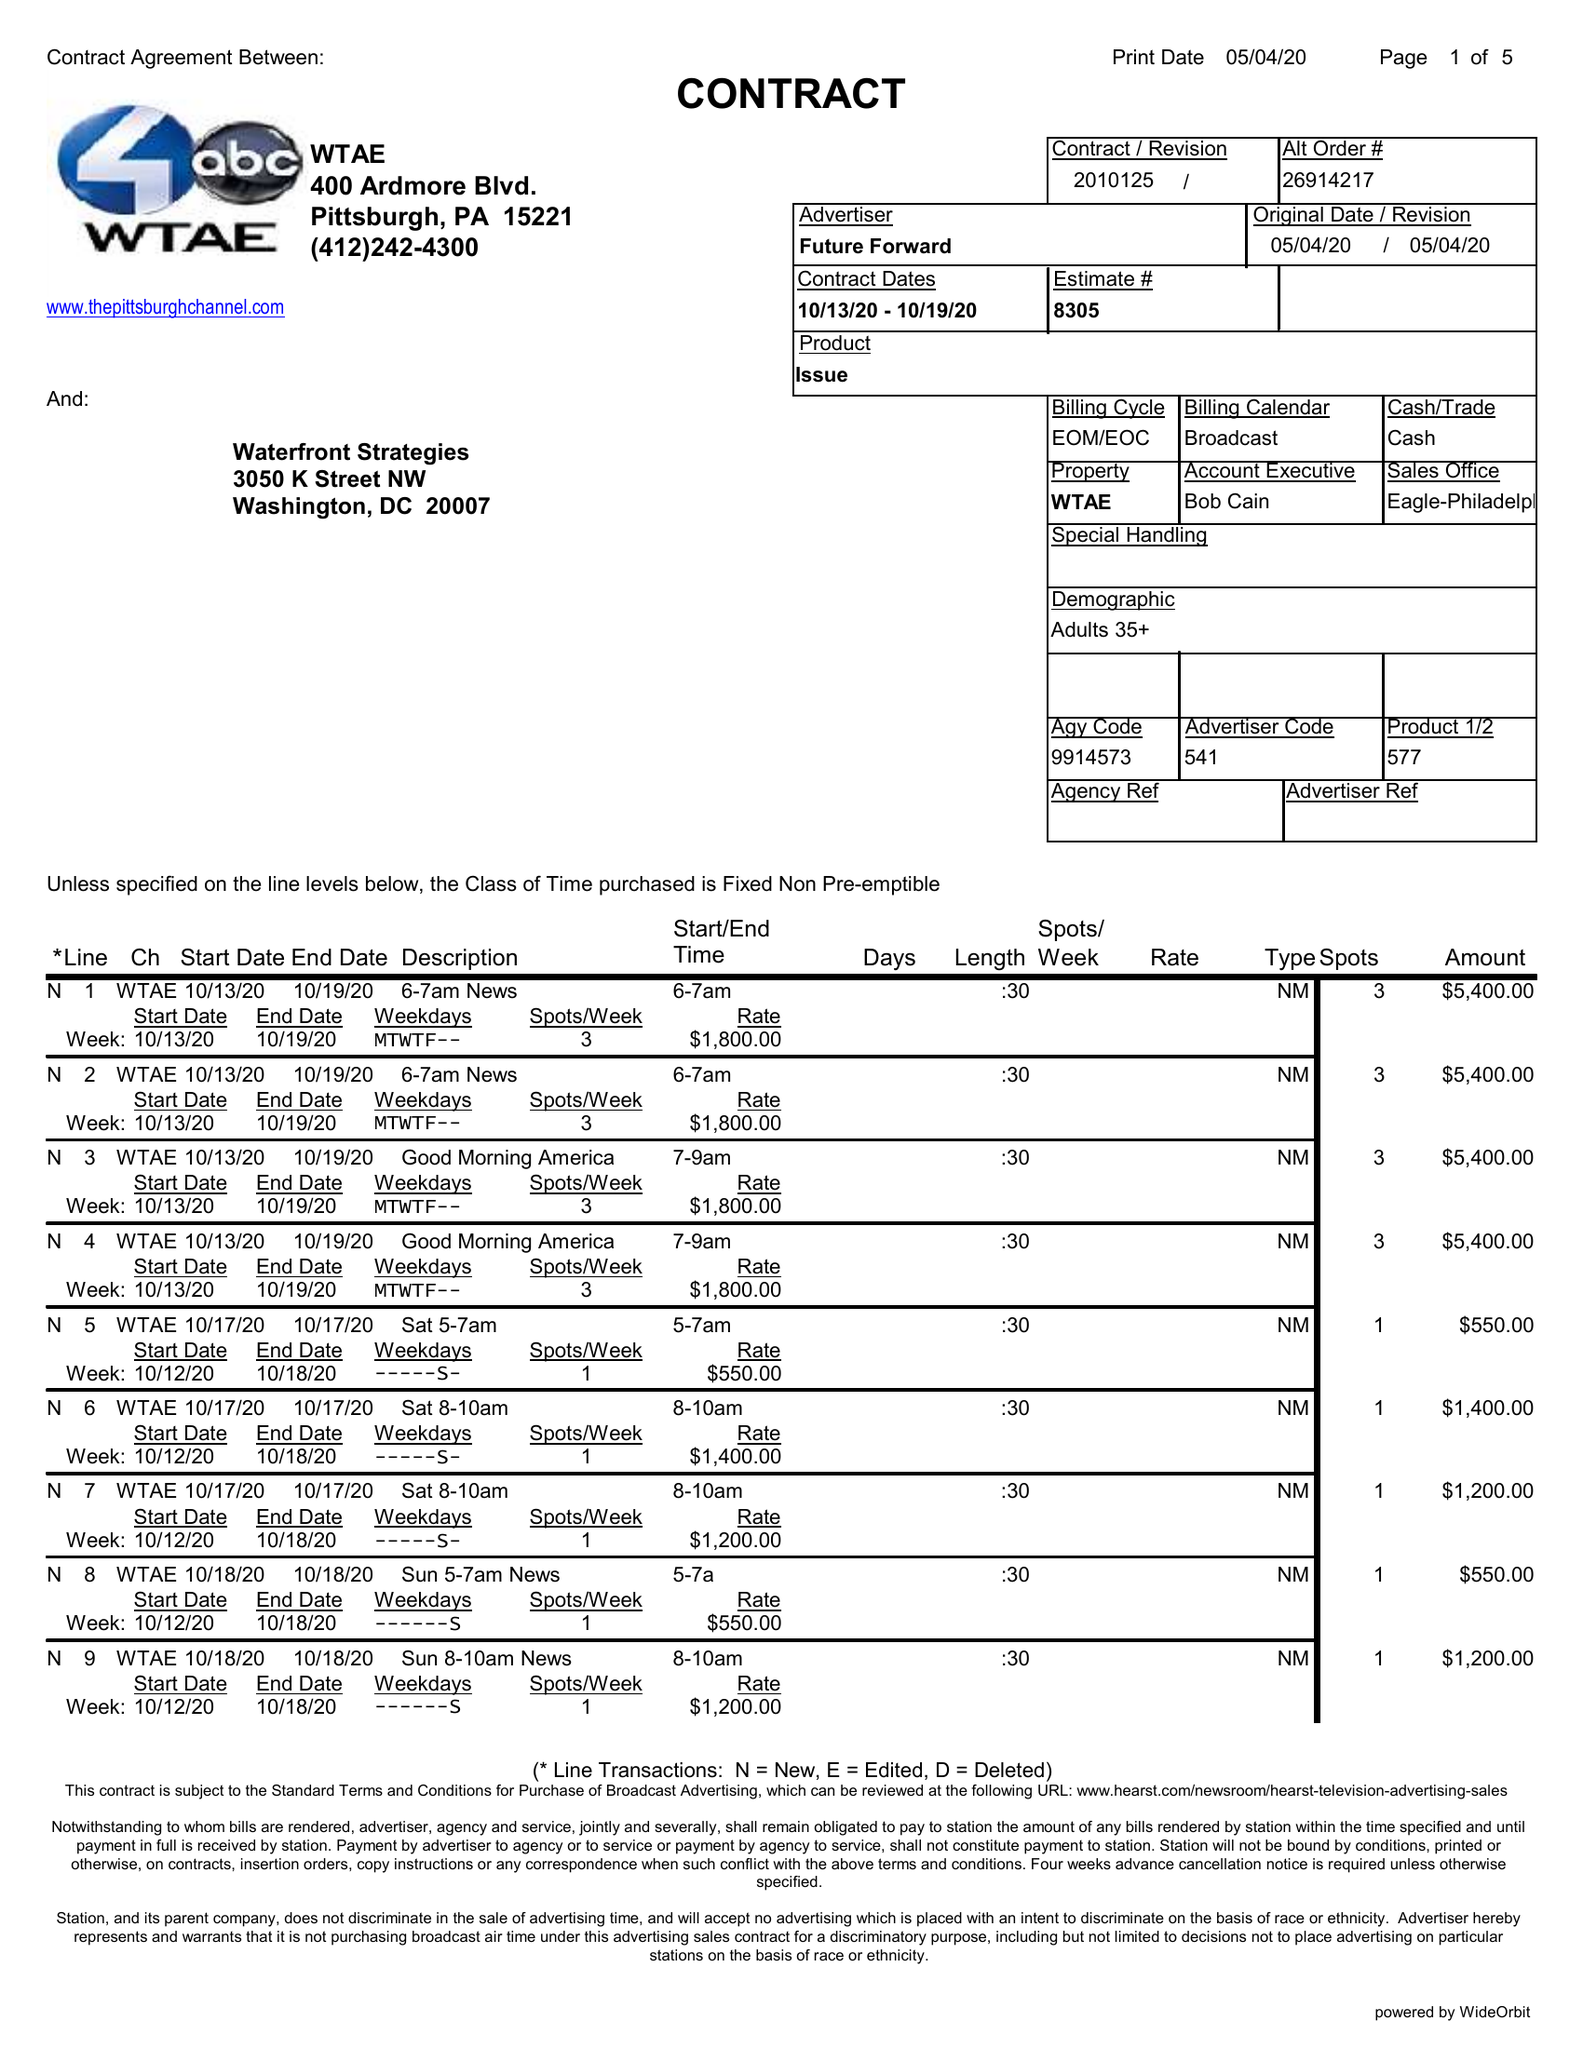What is the value for the contract_num?
Answer the question using a single word or phrase. 2010125 